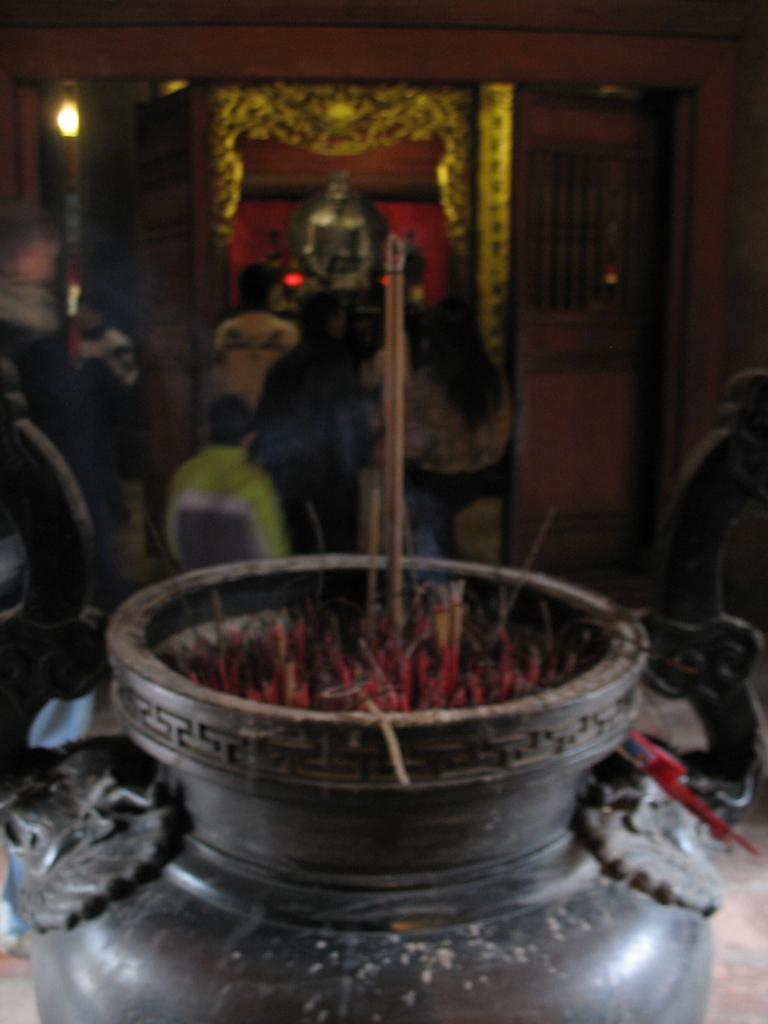What can be seen burning in the image? There are incense sticks in the image. What is happening in the background of the image? There is a group of people standing in the background. What is the main object in the image besides the incense sticks? There is a statue in the image. What is providing illumination in the image? There is a light in the image. What architectural feature is present in the image? There is a door in the image. What type of support does the rose need in the image? There is no rose present in the image, so it does not require any support. What role does the dad play in the image? There is no mention of a dad or any person in the image, so it is impossible to determine their role. 